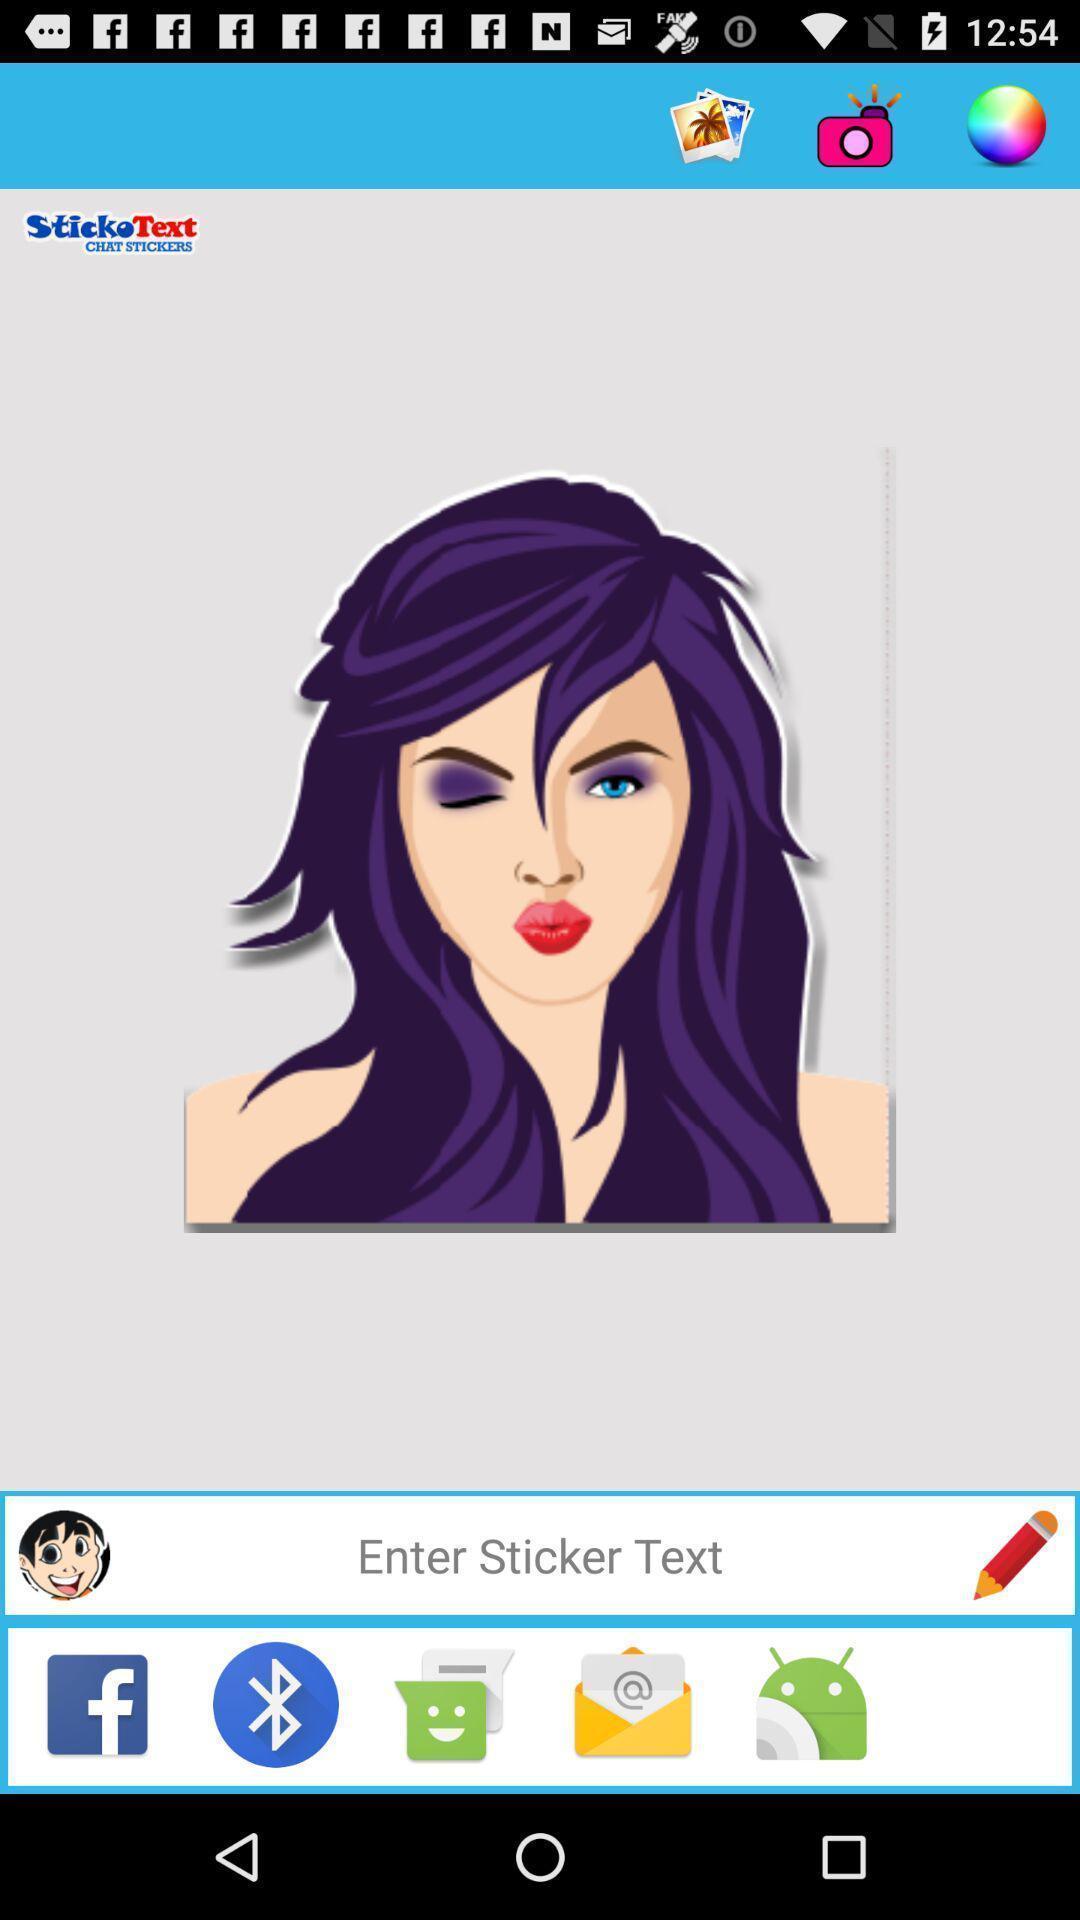Describe the key features of this screenshot. Page showing various options on mobile app. 